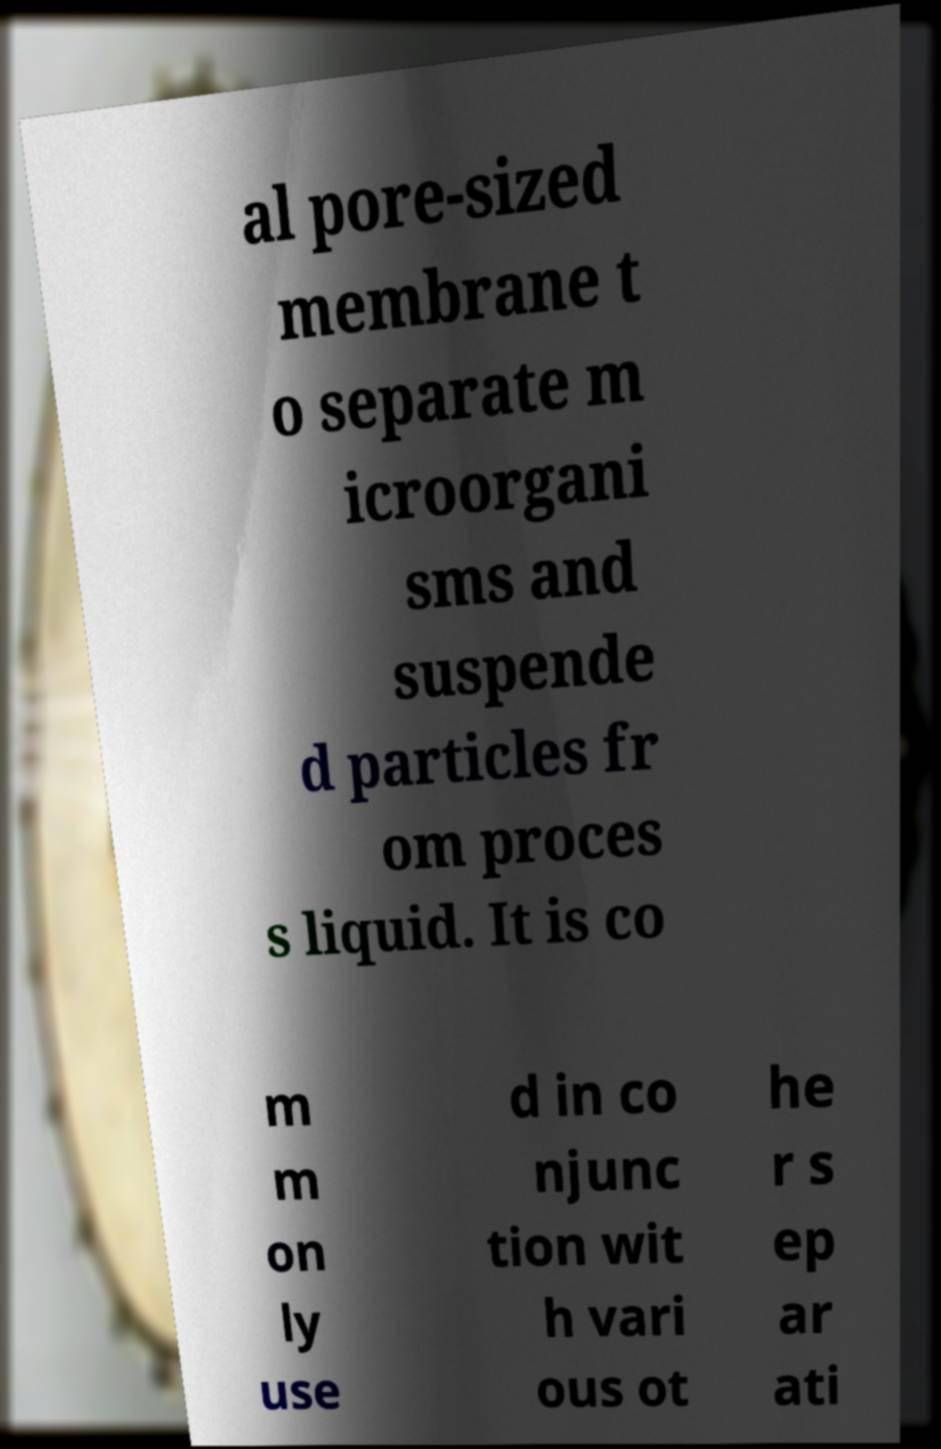I need the written content from this picture converted into text. Can you do that? al pore-sized membrane t o separate m icroorgani sms and suspende d particles fr om proces s liquid. It is co m m on ly use d in co njunc tion wit h vari ous ot he r s ep ar ati 